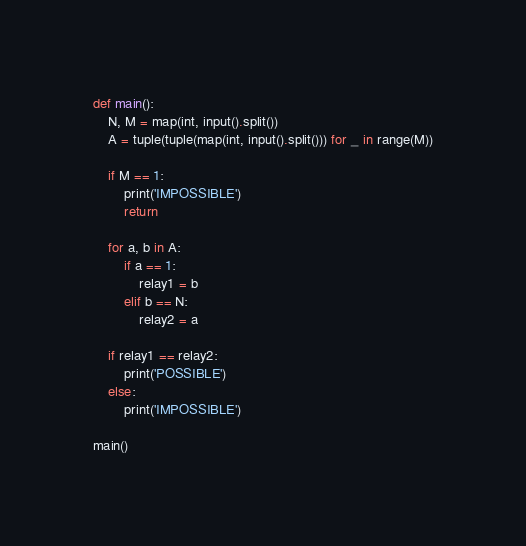<code> <loc_0><loc_0><loc_500><loc_500><_Python_>def main():
    N, M = map(int, input().split())
    A = tuple(tuple(map(int, input().split())) for _ in range(M))

    if M == 1:
        print('IMPOSSIBLE')
        return

    for a, b in A:
        if a == 1:
            relay1 = b
        elif b == N:
            relay2 = a

    if relay1 == relay2:
        print('POSSIBLE')
    else:
        print('IMPOSSIBLE')

main()
</code> 